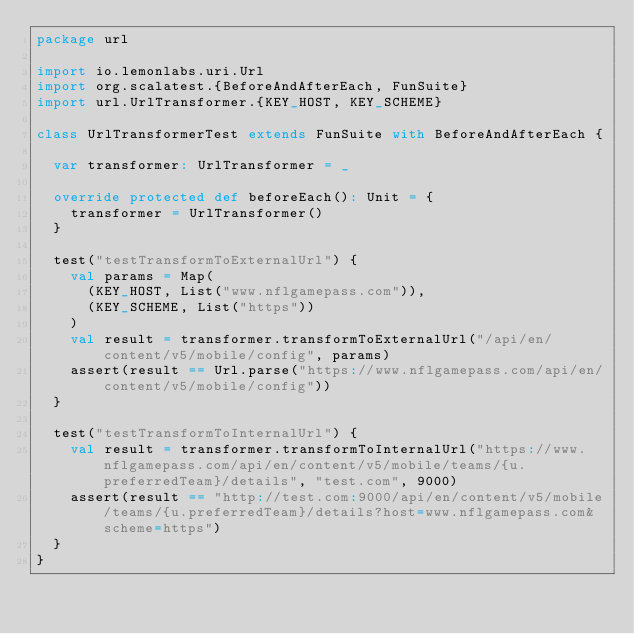<code> <loc_0><loc_0><loc_500><loc_500><_Scala_>package url

import io.lemonlabs.uri.Url
import org.scalatest.{BeforeAndAfterEach, FunSuite}
import url.UrlTransformer.{KEY_HOST, KEY_SCHEME}

class UrlTransformerTest extends FunSuite with BeforeAndAfterEach {

  var transformer: UrlTransformer = _

  override protected def beforeEach(): Unit = {
    transformer = UrlTransformer()
  }

  test("testTransformToExternalUrl") {
    val params = Map(
      (KEY_HOST, List("www.nflgamepass.com")),
      (KEY_SCHEME, List("https"))
    )
    val result = transformer.transformToExternalUrl("/api/en/content/v5/mobile/config", params)
    assert(result == Url.parse("https://www.nflgamepass.com/api/en/content/v5/mobile/config"))
  }

  test("testTransformToInternalUrl") {
    val result = transformer.transformToInternalUrl("https://www.nflgamepass.com/api/en/content/v5/mobile/teams/{u.preferredTeam}/details", "test.com", 9000)
    assert(result == "http://test.com:9000/api/en/content/v5/mobile/teams/{u.preferredTeam}/details?host=www.nflgamepass.com&scheme=https")
  }
}
</code> 